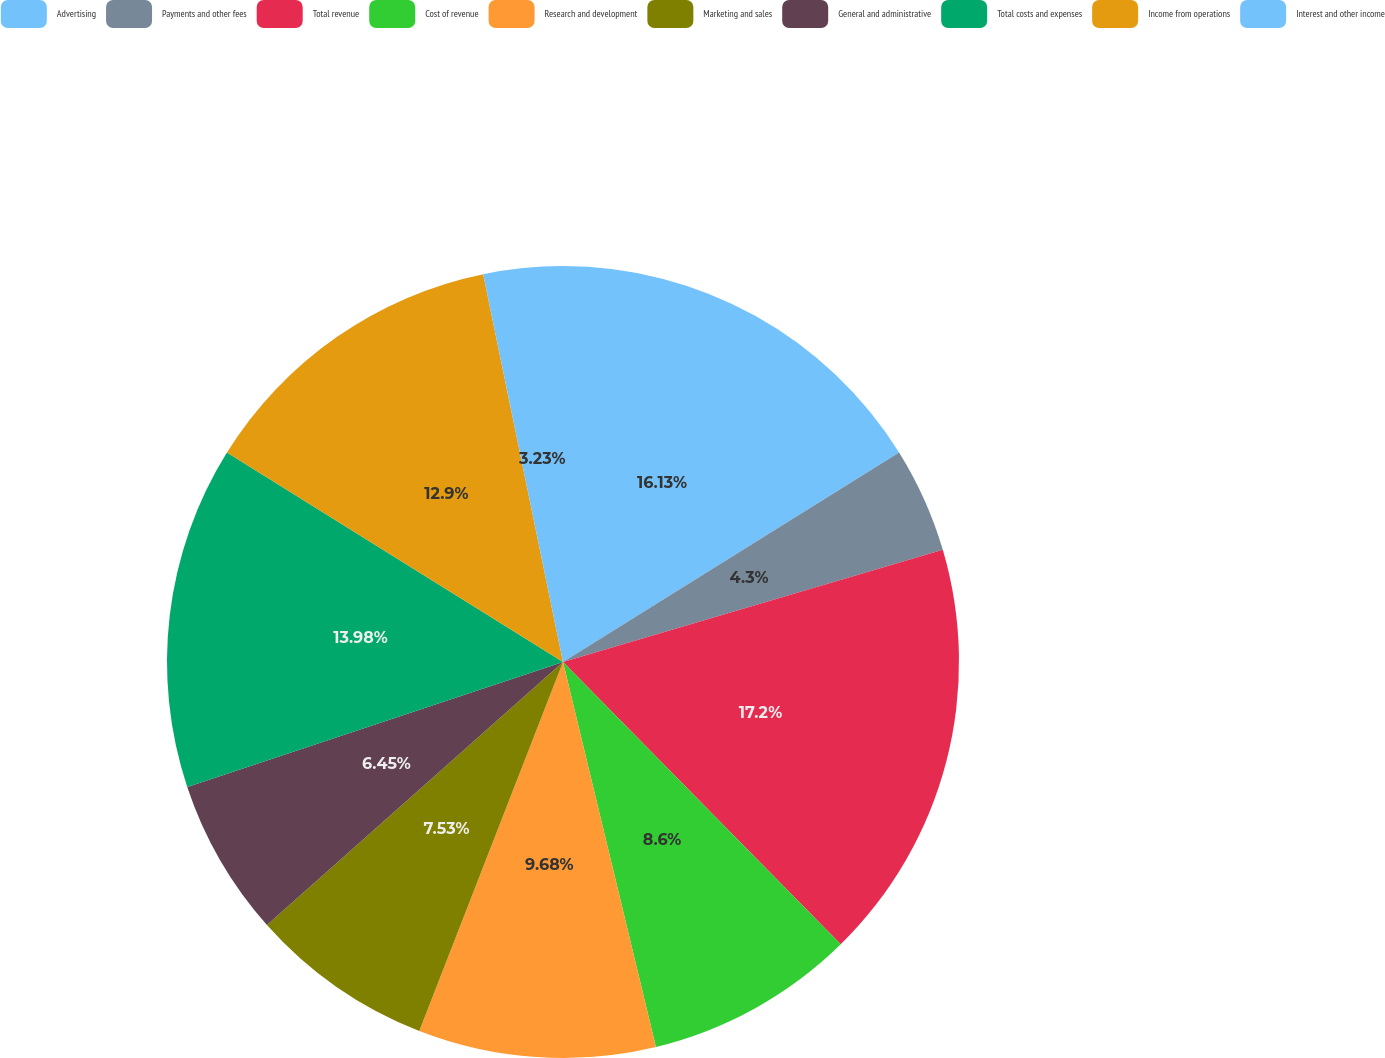Convert chart to OTSL. <chart><loc_0><loc_0><loc_500><loc_500><pie_chart><fcel>Advertising<fcel>Payments and other fees<fcel>Total revenue<fcel>Cost of revenue<fcel>Research and development<fcel>Marketing and sales<fcel>General and administrative<fcel>Total costs and expenses<fcel>Income from operations<fcel>Interest and other income<nl><fcel>16.13%<fcel>4.3%<fcel>17.2%<fcel>8.6%<fcel>9.68%<fcel>7.53%<fcel>6.45%<fcel>13.98%<fcel>12.9%<fcel>3.23%<nl></chart> 